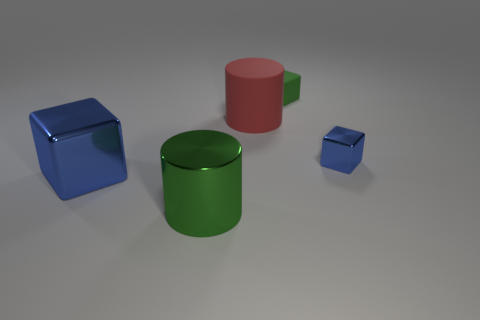Subtract all yellow blocks. Subtract all purple cylinders. How many blocks are left? 3 Add 3 big matte cylinders. How many objects exist? 8 Subtract all cylinders. How many objects are left? 3 Add 1 big balls. How many big balls exist? 1 Subtract 0 red cubes. How many objects are left? 5 Subtract all small matte things. Subtract all rubber things. How many objects are left? 2 Add 5 large blue metallic cubes. How many large blue metallic cubes are left? 6 